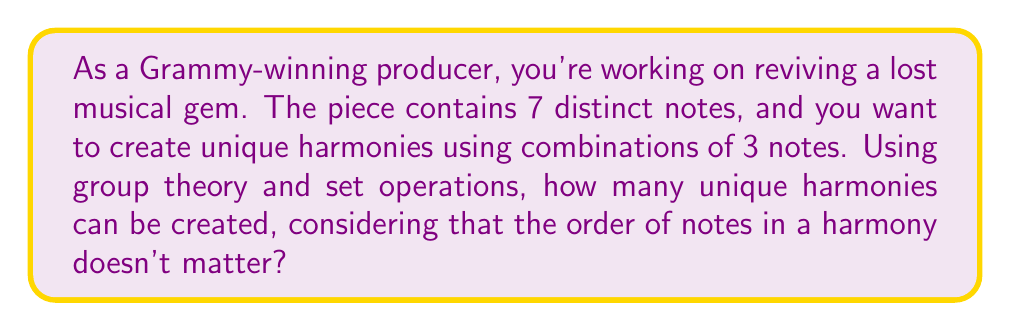Can you solve this math problem? Let's approach this step-by-step using group theory and set operations:

1) First, we need to understand that we're dealing with combinations, not permutations, because the order of notes in a harmony doesn't matter. This is equivalent to choosing subsets of size 3 from a set of 7 elements.

2) In group theory, this is related to the concept of orbits under the action of the symmetric group $S_3$ on 3-element subsets of a 7-element set.

3) The number of unique harmonies is equal to the number of these orbits, which can be calculated using Burnside's lemma:

   $$ |X/G| = \frac{1}{|G|} \sum_{g \in G} |X^g| $$

   Where $X$ is the set of all 3-element subsets of a 7-element set, $G$ is the symmetric group $S_3$, and $X^g$ is the set of elements fixed by $g$.

4) $|G| = |S_3| = 3! = 6$

5) Now, we need to count fixed points for each element of $S_3$:
   - Identity permutation: fixes all $\binom{7}{3} = 35$ subsets
   - 3 transpositions: each fixes $\binom{4}{1} = 4$ subsets
   - 2 3-cycles: fix no subsets

6) Applying Burnside's lemma:

   $$ |X/G| = \frac{1}{6}(35 + 4 + 4 + 4 + 0 + 0) = \frac{47}{6} = \frac{235}{30} $$

7) Since we're dealing with a whole number of harmonies, we need to simplify this fraction:

   $$ \frac{235}{30} = 7\frac{25}{30} = 7\frac{5}{6} = 7.833... $$

8) Rounding up to the nearest whole number (as we can't have a fractional number of harmonies), we get 8.
Answer: 8 unique harmonies 